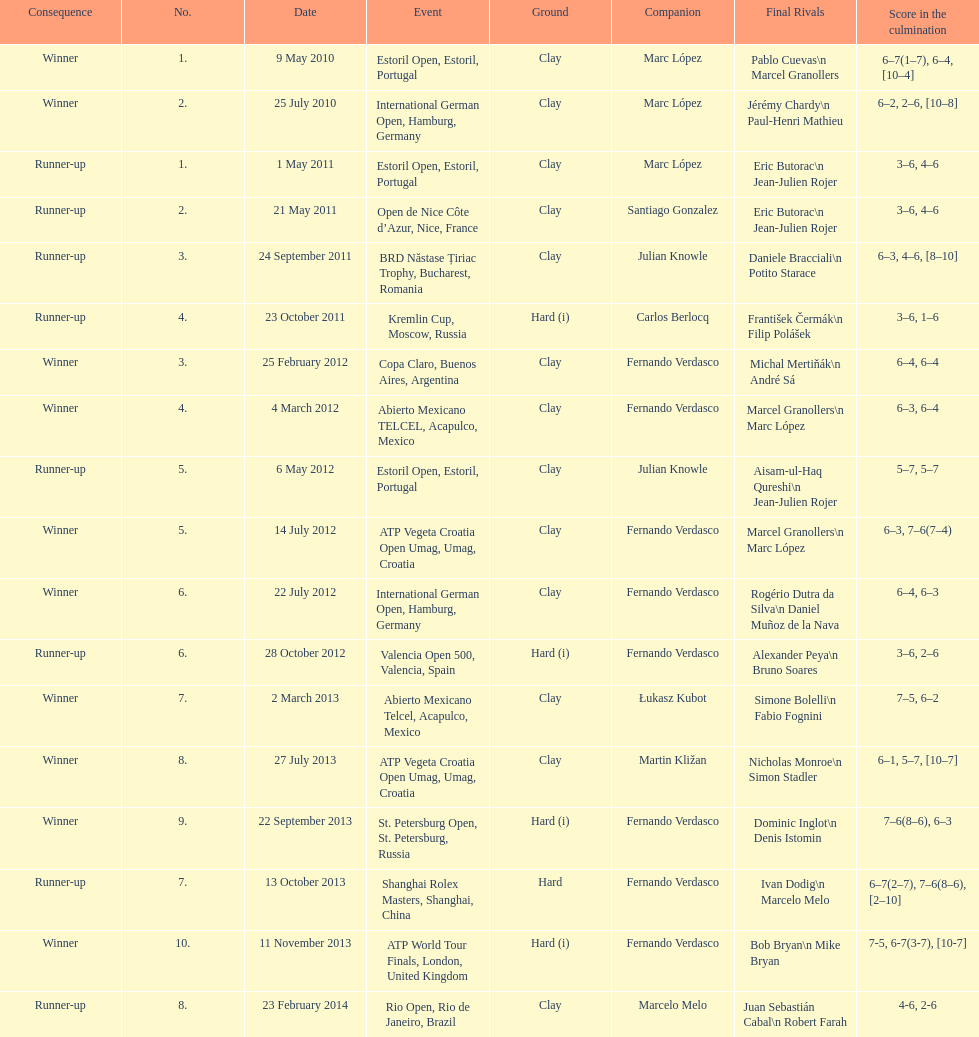How many runner-ups at most are listed? 8. 